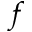<formula> <loc_0><loc_0><loc_500><loc_500>f</formula> 